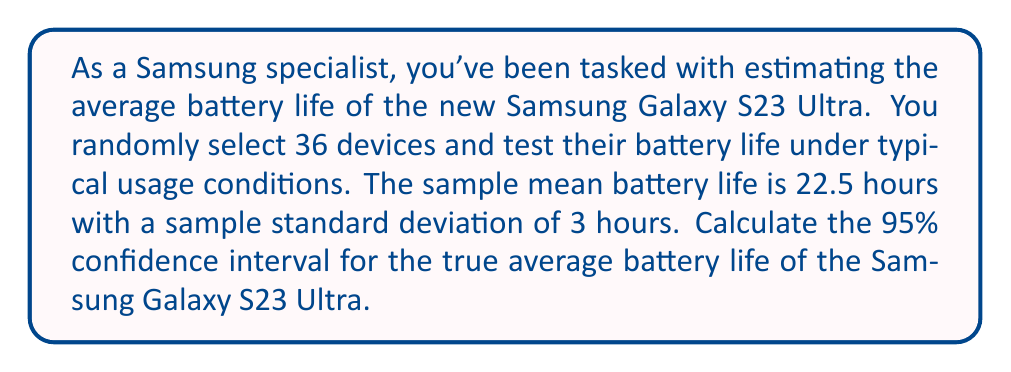Could you help me with this problem? Let's approach this step-by-step:

1) We're dealing with a confidence interval for a population mean with unknown population standard deviation. We'll use the t-distribution.

2) Given information:
   - Sample size: $n = 36$
   - Sample mean: $\bar{x} = 22.5$ hours
   - Sample standard deviation: $s = 3$ hours
   - Confidence level: 95% (α = 0.05)

3) The formula for the confidence interval is:

   $$\bar{x} \pm t_{\alpha/2, n-1} \cdot \frac{s}{\sqrt{n}}$$

4) We need to find $t_{\alpha/2, n-1}$:
   - Degrees of freedom: $df = n - 1 = 35$
   - For a 95% confidence interval, $\alpha/2 = 0.025$
   - From t-table or calculator: $t_{0.025, 35} \approx 2.030$

5) Calculate the margin of error:

   $$\text{Margin of Error} = t_{\alpha/2, n-1} \cdot \frac{s}{\sqrt{n}} = 2.030 \cdot \frac{3}{\sqrt{36}} \approx 1.015$$

6) Now we can calculate the confidence interval:

   $$22.5 \pm 1.015$$

7) Therefore, the 95% confidence interval is:

   $$(22.5 - 1.015, 22.5 + 1.015) = (21.485, 23.515)$$
Answer: (21.49, 23.52) hours 